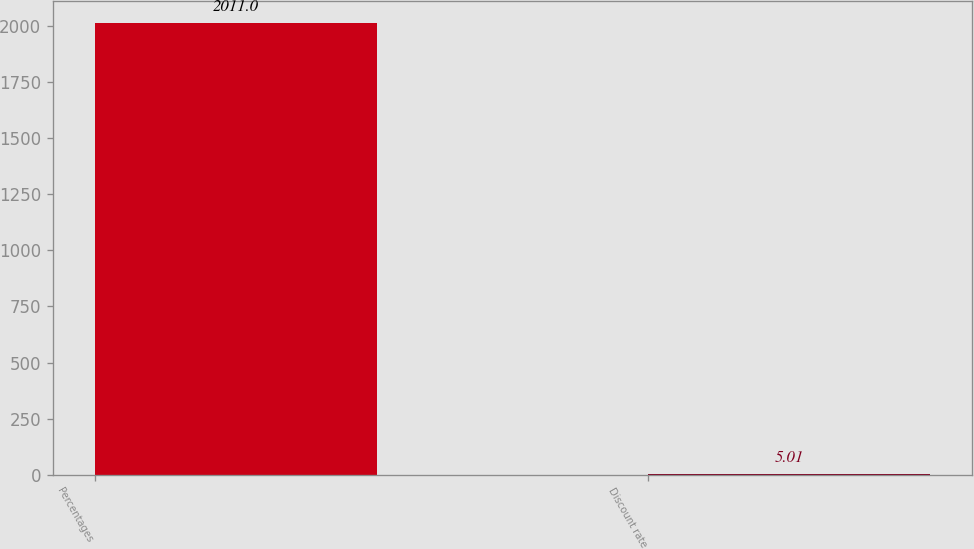Convert chart to OTSL. <chart><loc_0><loc_0><loc_500><loc_500><bar_chart><fcel>Percentages<fcel>Discount rate<nl><fcel>2011<fcel>5.01<nl></chart> 